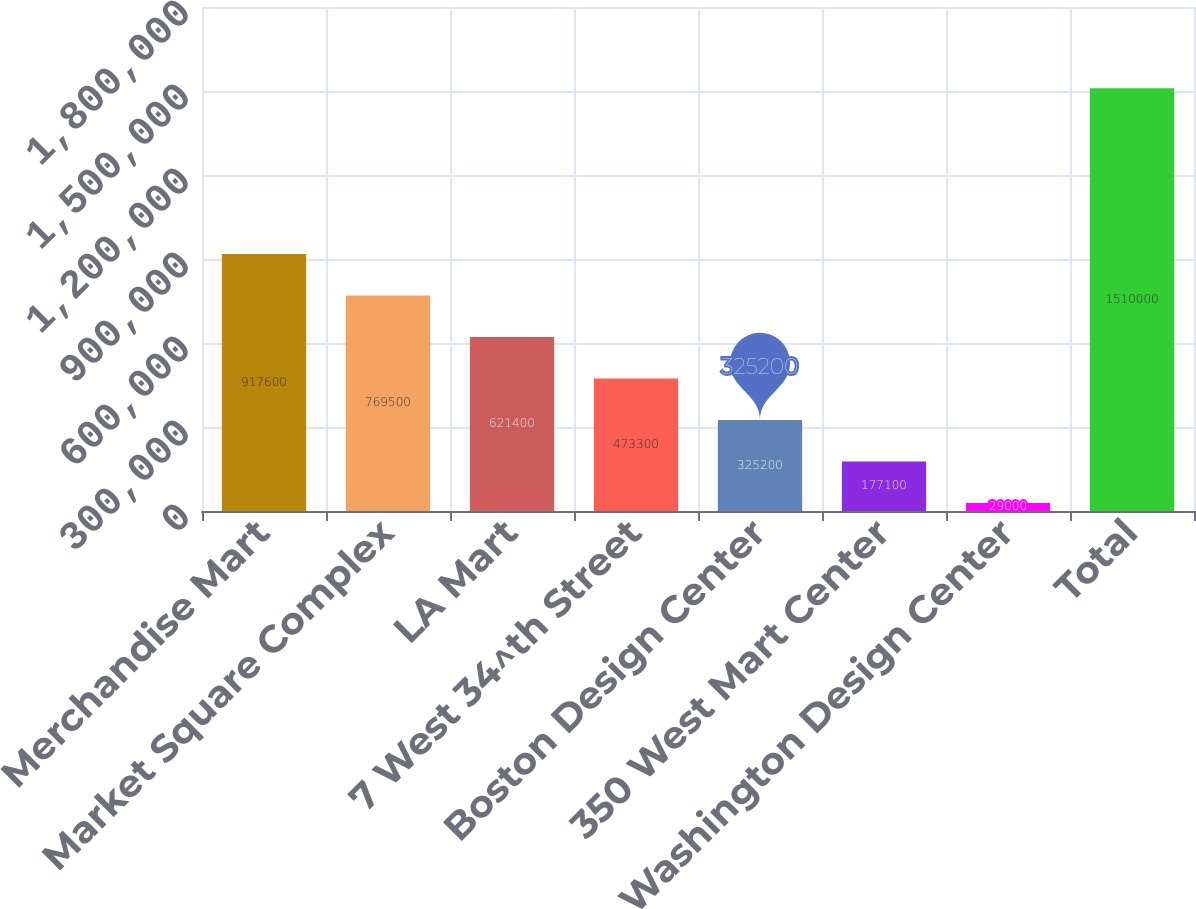Convert chart. <chart><loc_0><loc_0><loc_500><loc_500><bar_chart><fcel>Merchandise Mart<fcel>Market Square Complex<fcel>LA Mart<fcel>7 West 34^th Street<fcel>Boston Design Center<fcel>350 West Mart Center<fcel>Washington Design Center<fcel>Total<nl><fcel>917600<fcel>769500<fcel>621400<fcel>473300<fcel>325200<fcel>177100<fcel>29000<fcel>1.51e+06<nl></chart> 